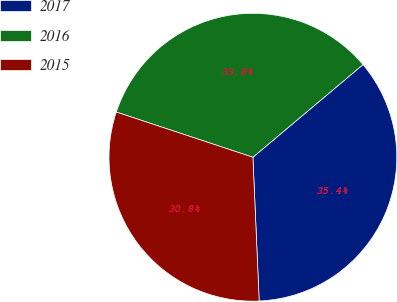Convert chart to OTSL. <chart><loc_0><loc_0><loc_500><loc_500><pie_chart><fcel>2017<fcel>2016<fcel>2015<nl><fcel>35.44%<fcel>33.78%<fcel>30.78%<nl></chart> 